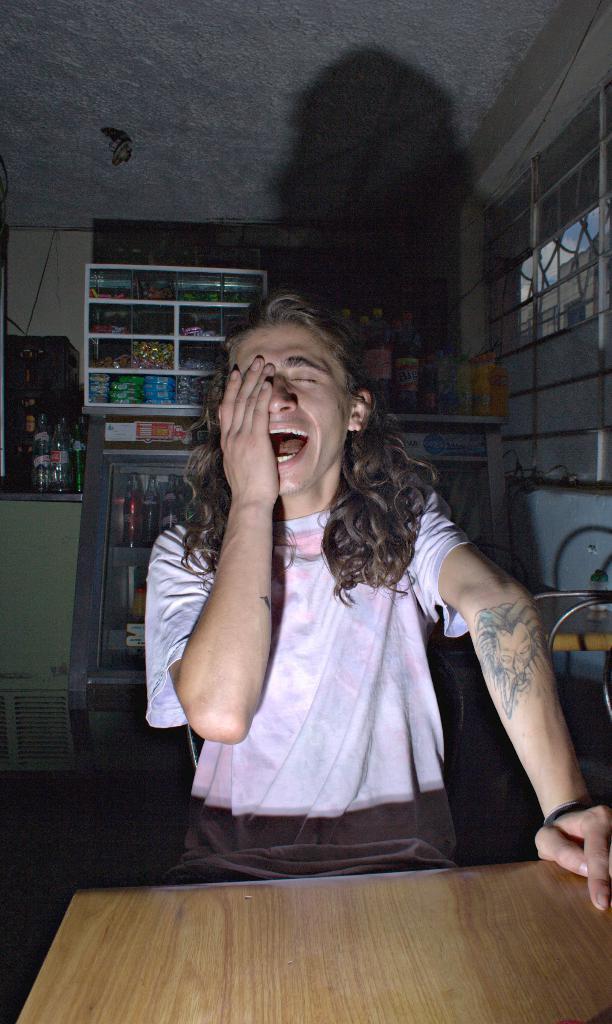How would you summarize this image in a sentence or two? A person in white color t-shirt, laughing and sitting. In front of him, there is a wooden table. In the background, there are different items in different shelves. Beside these shelves, there are bottles on the wall. Right to the person, there is a window. Top of him, there is a roof. 